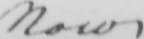What does this handwritten line say? Now 